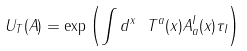<formula> <loc_0><loc_0><loc_500><loc_500>U _ { T } ( A ) = \exp { \left ( \int d ^ { x } \ T ^ { a } ( x ) A _ { a } ^ { I } ( x ) \tau _ { I } \right ) }</formula> 